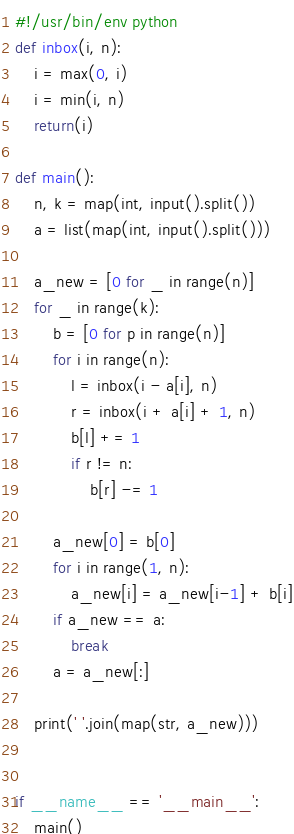<code> <loc_0><loc_0><loc_500><loc_500><_Python_>#!/usr/bin/env python
def inbox(i, n):
    i = max(0, i)
    i = min(i, n)
    return(i)

def main():
    n, k = map(int, input().split())
    a = list(map(int, input().split()))

    a_new = [0 for _ in range(n)]
    for _ in range(k):
        b = [0 for p in range(n)]
        for i in range(n):
            l = inbox(i - a[i], n)
            r = inbox(i + a[i] + 1, n)
            b[l] += 1
            if r != n:
                b[r] -= 1

        a_new[0] = b[0]
        for i in range(1, n):
            a_new[i] = a_new[i-1] + b[i]
        if a_new == a:
            break
        a = a_new[:]

    print(' '.join(map(str, a_new)))


if __name__ == '__main__':
    main()
</code> 